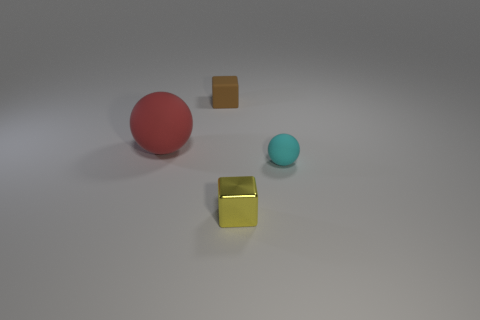What mood or atmosphere does the arrangement of these objects create? The arrangement of the objects, combined with the soft lighting and the neutral background, creates a calm and understated atmosphere. The simplicity of the scene and the spacing between items give off a minimalist vibe, which might evoke a sense of order and tranquility. 